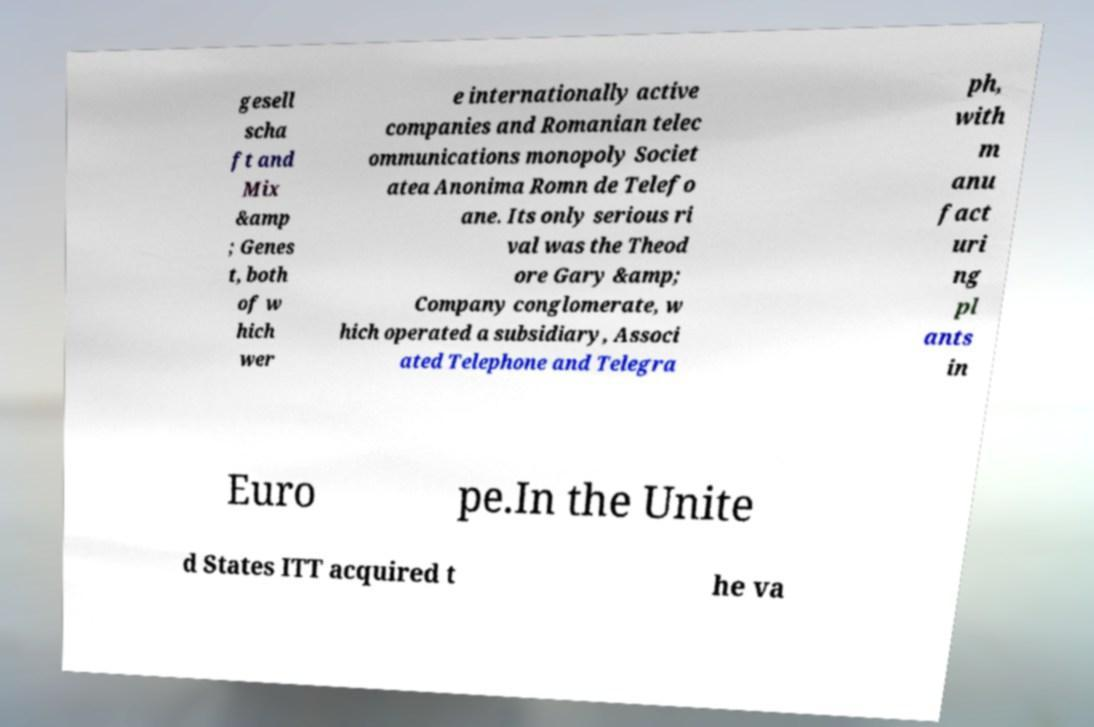I need the written content from this picture converted into text. Can you do that? gesell scha ft and Mix &amp ; Genes t, both of w hich wer e internationally active companies and Romanian telec ommunications monopoly Societ atea Anonima Romn de Telefo ane. Its only serious ri val was the Theod ore Gary &amp; Company conglomerate, w hich operated a subsidiary, Associ ated Telephone and Telegra ph, with m anu fact uri ng pl ants in Euro pe.In the Unite d States ITT acquired t he va 